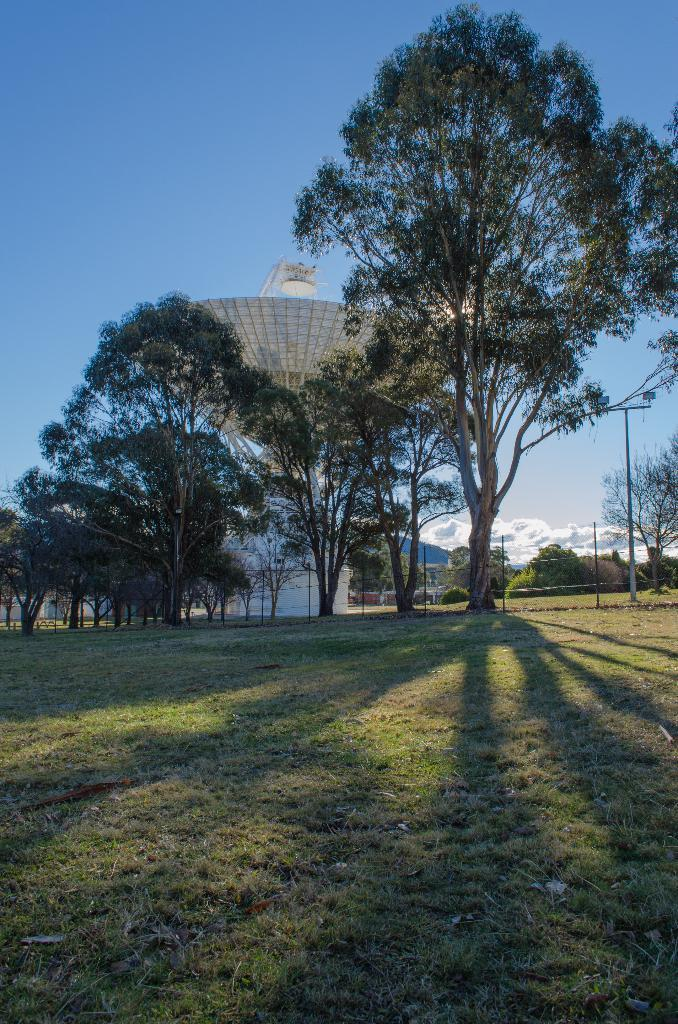What type of vegetation is present in the image? There is grass in the image. What is the main area covered by the grass in the image? There is a lawn in the image. What can be seen in the background of the image? There are trees, poles, and a tower in the background of the image. What is the condition of the sky in the background of the image? The sky is clear in the background of the image. How many machines are visible in the image? There are no machines present in the image. What type of army can be seen in the image? There is no army present in the image. 